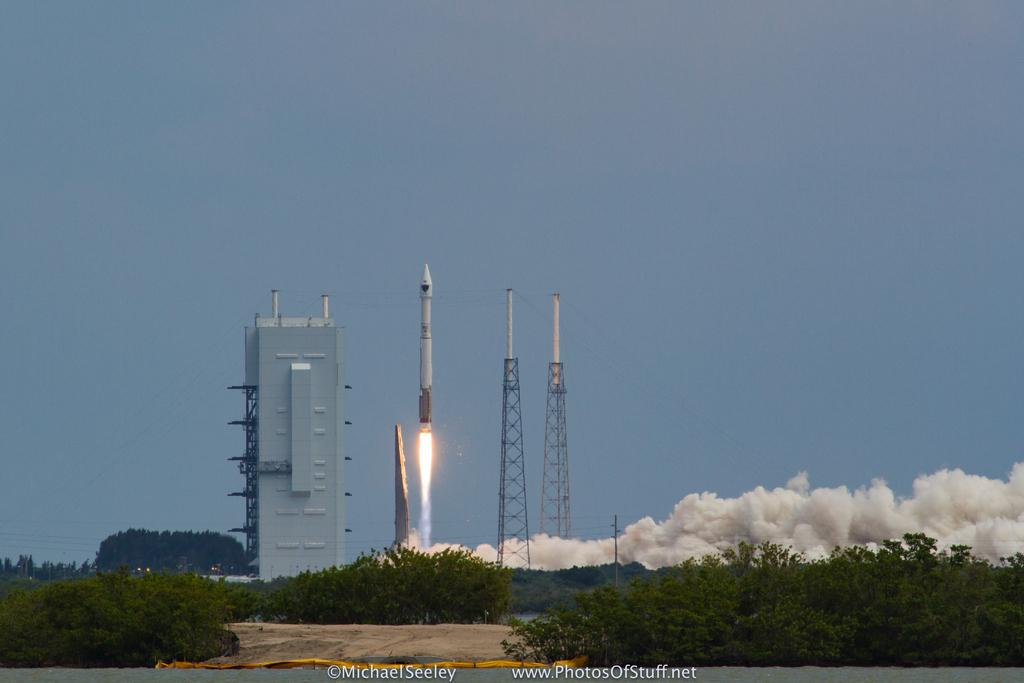What is the main subject of the image? There is a rocket in the image. What other structures can be seen in the image? There is a building and towers in the image. What type of vegetation is present in the image? There are trees in the image. What is the source of the smoke in the image? The smoke is likely a result of the rocket launch. What is visible in the background of the image? The sky is visible in the background of the image. How many times has the ladybug been folded in the image? There is no ladybug present in the image, so it cannot be folded or counted. 